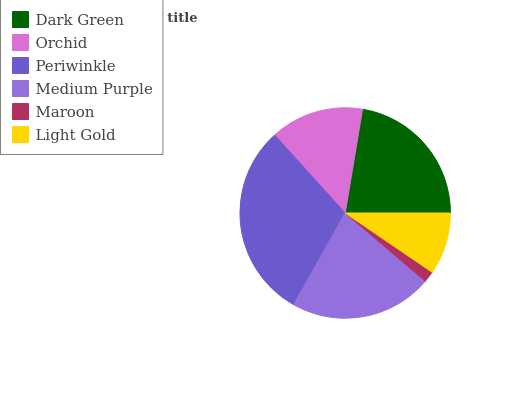Is Maroon the minimum?
Answer yes or no. Yes. Is Periwinkle the maximum?
Answer yes or no. Yes. Is Orchid the minimum?
Answer yes or no. No. Is Orchid the maximum?
Answer yes or no. No. Is Dark Green greater than Orchid?
Answer yes or no. Yes. Is Orchid less than Dark Green?
Answer yes or no. Yes. Is Orchid greater than Dark Green?
Answer yes or no. No. Is Dark Green less than Orchid?
Answer yes or no. No. Is Medium Purple the high median?
Answer yes or no. Yes. Is Orchid the low median?
Answer yes or no. Yes. Is Dark Green the high median?
Answer yes or no. No. Is Periwinkle the low median?
Answer yes or no. No. 